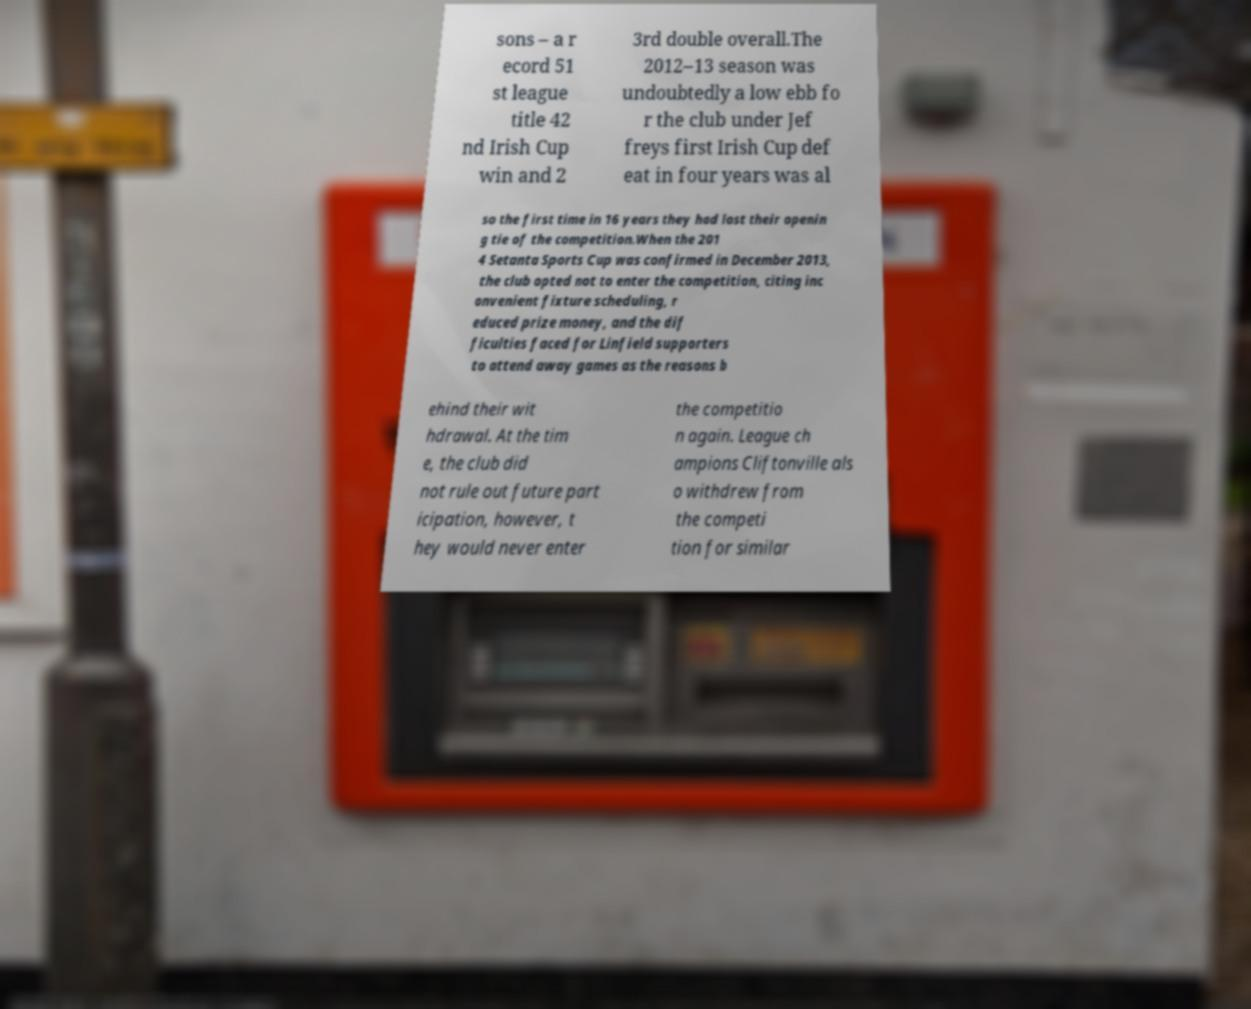Please identify and transcribe the text found in this image. sons – a r ecord 51 st league title 42 nd Irish Cup win and 2 3rd double overall.The 2012–13 season was undoubtedly a low ebb fo r the club under Jef freys first Irish Cup def eat in four years was al so the first time in 16 years they had lost their openin g tie of the competition.When the 201 4 Setanta Sports Cup was confirmed in December 2013, the club opted not to enter the competition, citing inc onvenient fixture scheduling, r educed prize money, and the dif ficulties faced for Linfield supporters to attend away games as the reasons b ehind their wit hdrawal. At the tim e, the club did not rule out future part icipation, however, t hey would never enter the competitio n again. League ch ampions Cliftonville als o withdrew from the competi tion for similar 